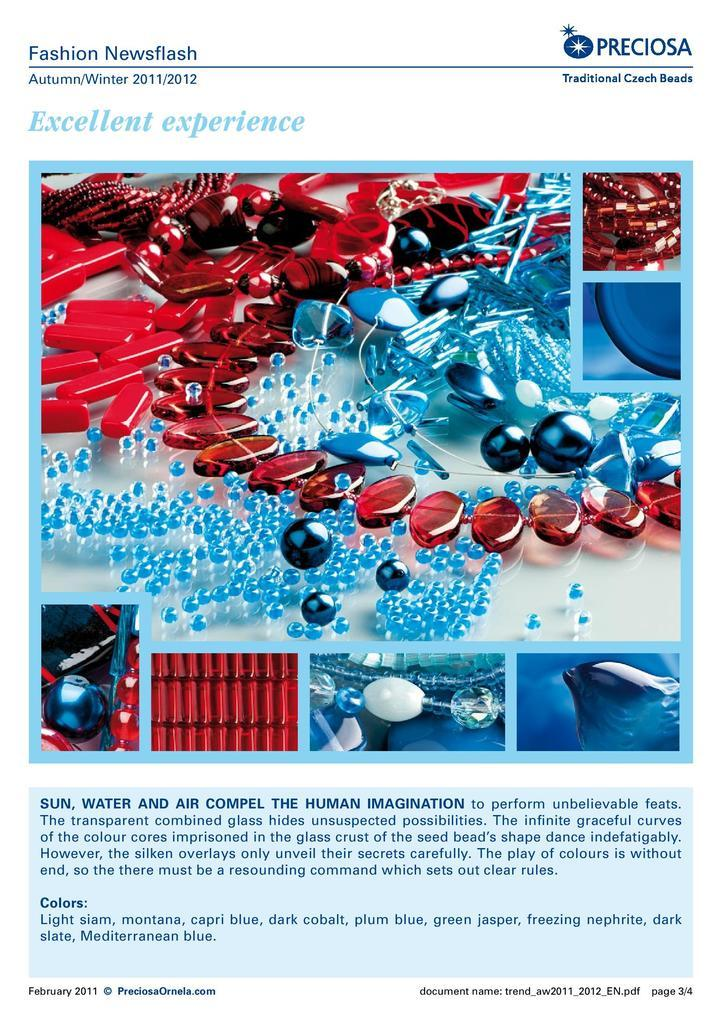What type of printed material is present in the image? There is a magazine in the image. Can you describe the text visible at the top of the image? There is text visible at the top of the image. Can you describe the text visible at the bottom of the image? There is text visible at the bottom of the image. How does the organization benefit from the throat rub in the image? There is no organization, throat, or rub present in the image. 